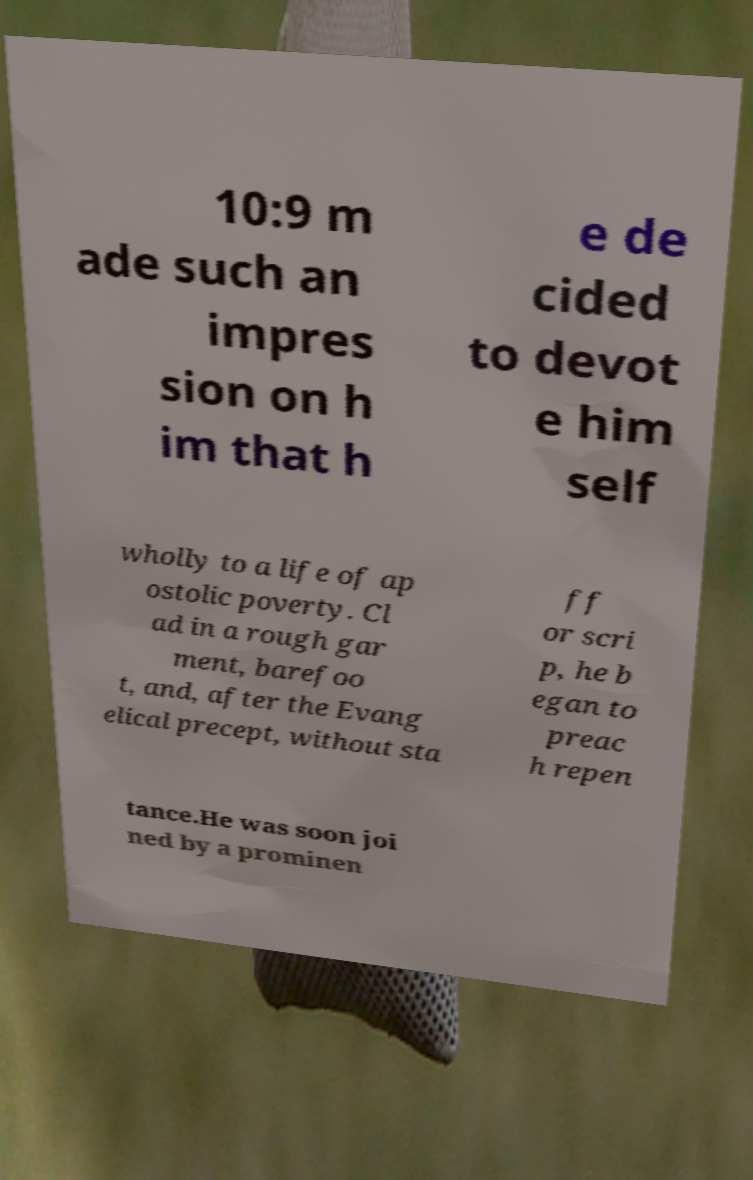Could you assist in decoding the text presented in this image and type it out clearly? 10:9 m ade such an impres sion on h im that h e de cided to devot e him self wholly to a life of ap ostolic poverty. Cl ad in a rough gar ment, barefoo t, and, after the Evang elical precept, without sta ff or scri p, he b egan to preac h repen tance.He was soon joi ned by a prominen 